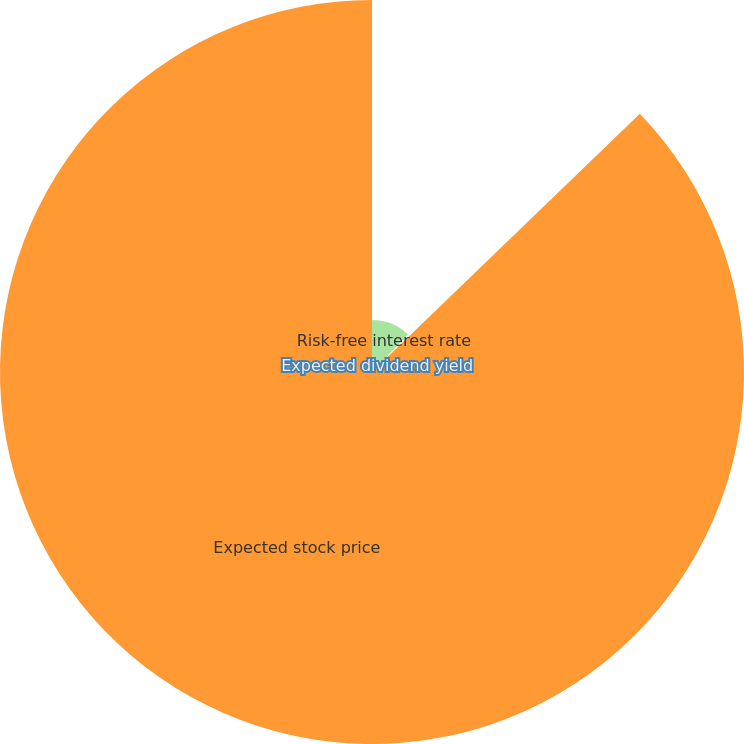Convert chart. <chart><loc_0><loc_0><loc_500><loc_500><pie_chart><fcel>Risk-free interest rate<fcel>Expected dividend yield<fcel>Expected stock price<nl><fcel>12.18%<fcel>0.61%<fcel>87.2%<nl></chart> 